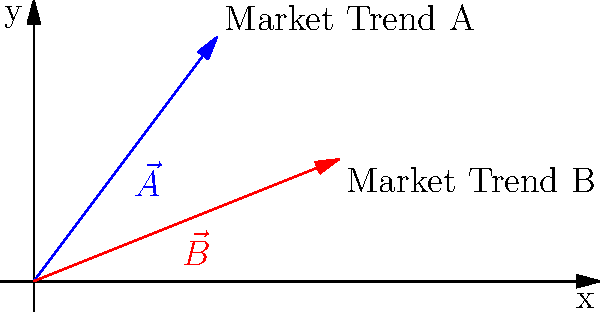As a PR executive, you're analyzing two market trends represented by vectors $\vec{A}$ and $\vec{B}$ in the graph. Vector $\vec{A}$ has components (3, 4), while vector $\vec{B}$ has components (5, 2). Which market trend has a greater magnitude, and by how much? To compare the magnitude of two vectors, we need to calculate their lengths using the Pythagorean theorem.

For vector $\vec{A}$:
1. $|\vec{A}| = \sqrt{3^2 + 4^2}$
2. $|\vec{A}| = \sqrt{9 + 16}$
3. $|\vec{A}| = \sqrt{25} = 5$

For vector $\vec{B}$:
1. $|\vec{B}| = \sqrt{5^2 + 2^2}$
2. $|\vec{B}| = \sqrt{25 + 4}$
3. $|\vec{B}| = \sqrt{29} \approx 5.39$

Comparing the magnitudes:
$|\vec{B}| - |\vec{A}| \approx 5.39 - 5 = 0.39$

Therefore, market trend B (represented by vector $\vec{B}$) has a greater magnitude, and it exceeds market trend A by approximately 0.39 units.
Answer: Market trend B, by 0.39 units. 